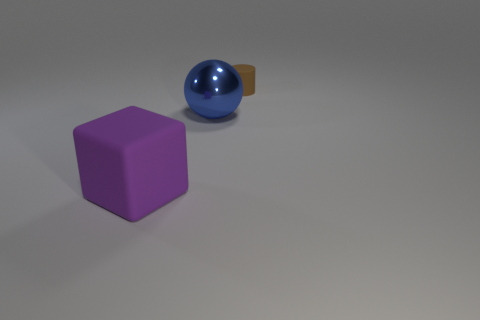What can you infer about the lighting in the scene? The lighting in the scene appears to be diffused with a single light source. Shadows are soft and there are no harsh highlights, indicating the light source is not extremely close to the objects.  Does the surface on which the objects rest have any texture? The surface appears smooth without any visible texture or grain, creating a clean backdrop for the objects in the image. 